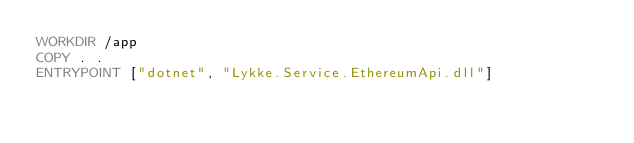<code> <loc_0><loc_0><loc_500><loc_500><_Dockerfile_>WORKDIR /app
COPY . .
ENTRYPOINT ["dotnet", "Lykke.Service.EthereumApi.dll"]
</code> 